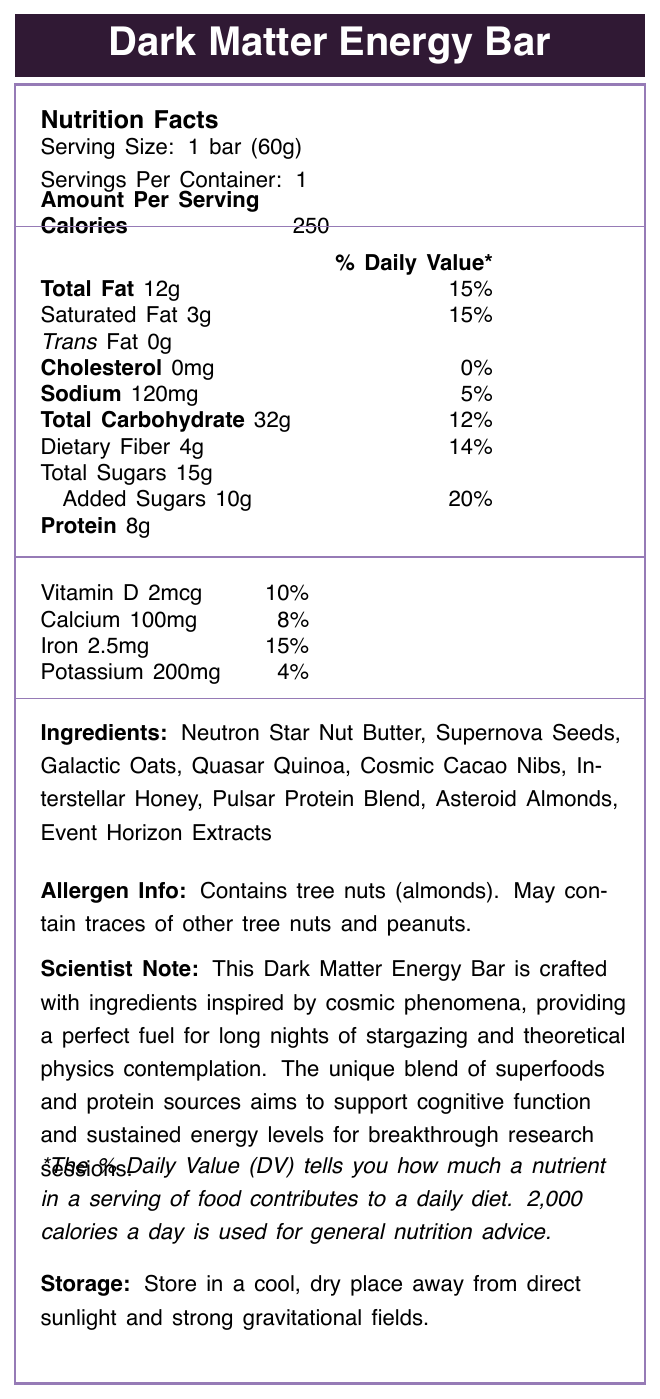what is the serving size of the Dark Matter Energy Bar? The document specifies that each serving size of the Dark Matter Energy Bar is 1 bar, which weighs 60 grams.
Answer: 1 bar (60g) how many calories are there in one serving of the Dark Matter Energy Bar? The document states that there are 250 calories per serving.
Answer: 250 what percentage of the Daily Value does the Total Fat content represent? The Total Fat content is 12g, and this represents 15% of the Daily Value according to the document.
Answer: 15% which ingredient contains tree nuts? The document specifies that the energy bar contains almonds, which are tree nuts.
Answer: Asteroid Almonds what is the amount of protein in one Dark Matter Energy Bar? The document indicates that there are 8 grams of protein per serving.
Answer: 8g Does the Dark Matter Energy Bar contain cholesterol? The document lists the cholesterol content as 0mg, indicating that it does not contain any cholesterol.
Answer: No what is the purpose of including scientific notes in the document? A. To provide nutritional information B. To advertise the product C. To suggest usage scenarios for scientists D. To indicate allergy information The scientific note provides scenarios where the energy bar can be useful for scientists, such as theoretical physics contemplation and long nights of stargazing.
Answer: C which of the following is a source of added sugars? A. Quasar Quinoa B. Interstellar Honey C. Galactic Oats D. Event Horizon Extracts The document lists Interstellar Honey as one of the ingredients, which can be a source of added sugars.
Answer: B is the percentage of Daily Value for vitamin D significant or not? The document states that the vitamin D content is 2mcg, which represents 10% of the Daily Value, a relatively significant amount.
Answer: Yes summarize the main idea of the document. This summary encompasses all the main elements in the document, including nutritional details, special ingredients, allergen warnings, a tailored note for scientists, and proper storage guidelines.
Answer: The document is a nutrition facts label for the Dark Matter Energy Bar, detailing its serving size, calories, macronutrient and micronutrient content, cosmic-inspired ingredients, allergen information, a note for scientists to suggest usage scenarios, and storage instructions. what is the source of dietary fiber in the Dark Matter Energy Bar? The document lists various ingredients but does not specify which one is the source of dietary fiber.
Answer: Not enough information what is the main inspiration behind the ingredients in the Dark Matter Energy Bar? The document mentions that the ingredients are inspired by cosmic phenomena, aiming to support cognitive function and sustained energy levels.
Answer: Cosmic phenomena 